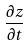<formula> <loc_0><loc_0><loc_500><loc_500>\frac { \partial z } { \partial t }</formula> 